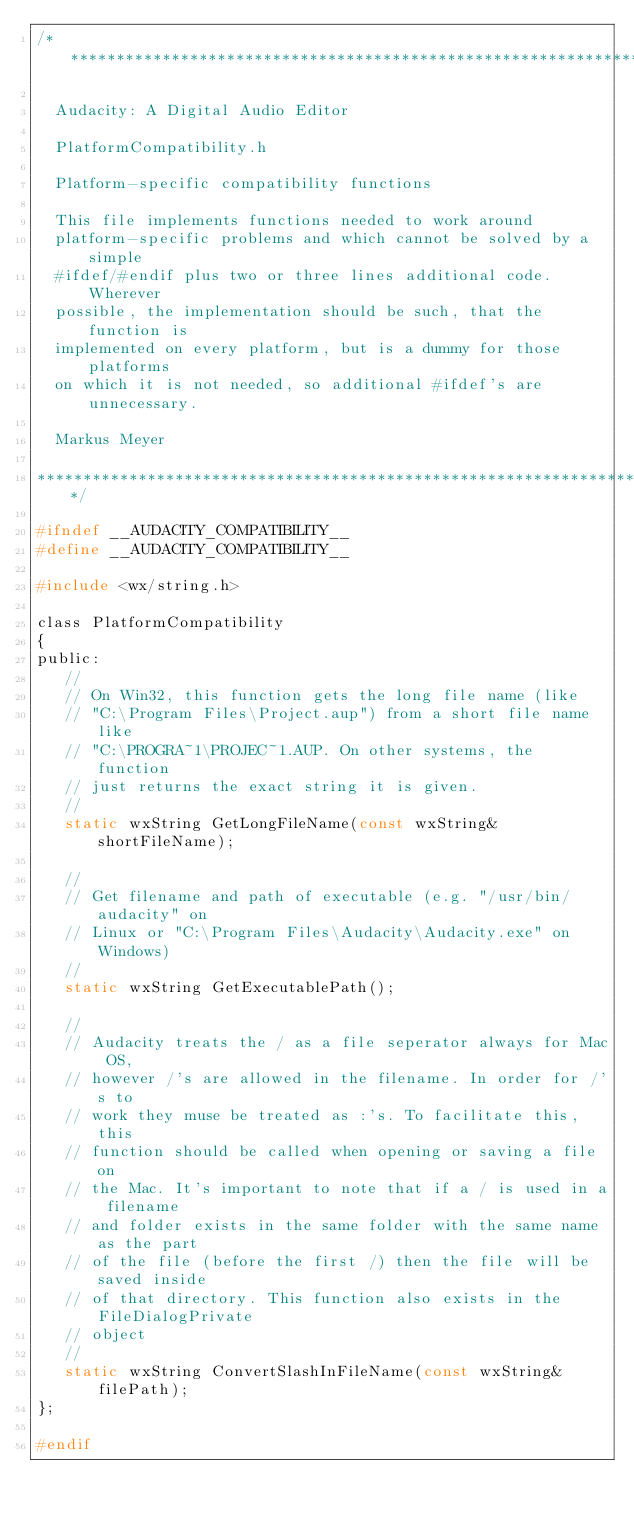Convert code to text. <code><loc_0><loc_0><loc_500><loc_500><_C_>/**********************************************************************

  Audacity: A Digital Audio Editor

  PlatformCompatibility.h

  Platform-specific compatibility functions

  This file implements functions needed to work around
  platform-specific problems and which cannot be solved by a simple
  #ifdef/#endif plus two or three lines additional code. Wherever
  possible, the implementation should be such, that the function is
  implemented on every platform, but is a dummy for those platforms
  on which it is not needed, so additional #ifdef's are unnecessary.

  Markus Meyer

**********************************************************************/

#ifndef __AUDACITY_COMPATIBILITY__
#define __AUDACITY_COMPATIBILITY__

#include <wx/string.h>

class PlatformCompatibility
{
public:
   //
   // On Win32, this function gets the long file name (like
   // "C:\Program Files\Project.aup") from a short file name like
   // "C:\PROGRA~1\PROJEC~1.AUP. On other systems, the function
   // just returns the exact string it is given.
   //
   static wxString GetLongFileName(const wxString& shortFileName);

   //
   // Get filename and path of executable (e.g. "/usr/bin/audacity" on
   // Linux or "C:\Program Files\Audacity\Audacity.exe" on Windows)
   //
   static wxString GetExecutablePath();

   //
   // Audacity treats the / as a file seperator always for Mac OS,
   // however /'s are allowed in the filename. In order for /'s to
   // work they muse be treated as :'s. To facilitate this, this
   // function should be called when opening or saving a file on
   // the Mac. It's important to note that if a / is used in a filename
   // and folder exists in the same folder with the same name as the part
   // of the file (before the first /) then the file will be saved inside
   // of that directory. This function also exists in the FileDialogPrivate
   // object
   //
   static wxString ConvertSlashInFileName(const wxString& filePath);
};

#endif
</code> 